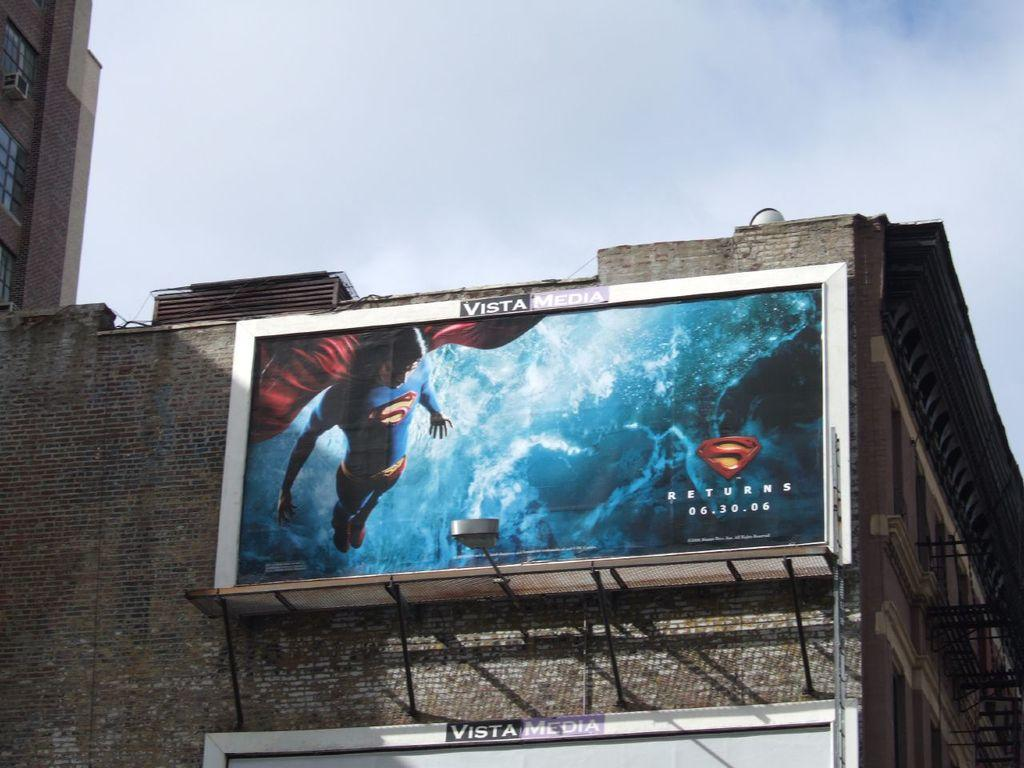<image>
Share a concise interpretation of the image provided. A large Superman billboard on the side of a building. 